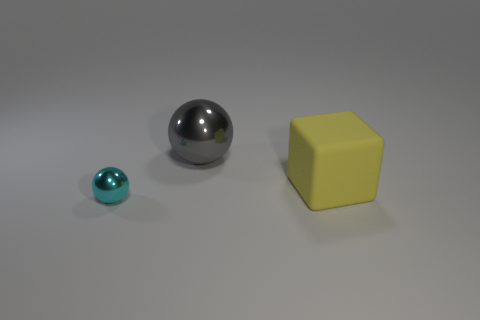Add 1 large metallic balls. How many objects exist? 4 Subtract all cyan balls. How many balls are left? 1 Subtract all blocks. How many objects are left? 2 Add 3 large brown spheres. How many large brown spheres exist? 3 Subtract 0 cyan cubes. How many objects are left? 3 Subtract all red cubes. Subtract all red spheres. How many cubes are left? 1 Subtract all large yellow matte objects. Subtract all yellow cubes. How many objects are left? 1 Add 2 large metallic balls. How many large metallic balls are left? 3 